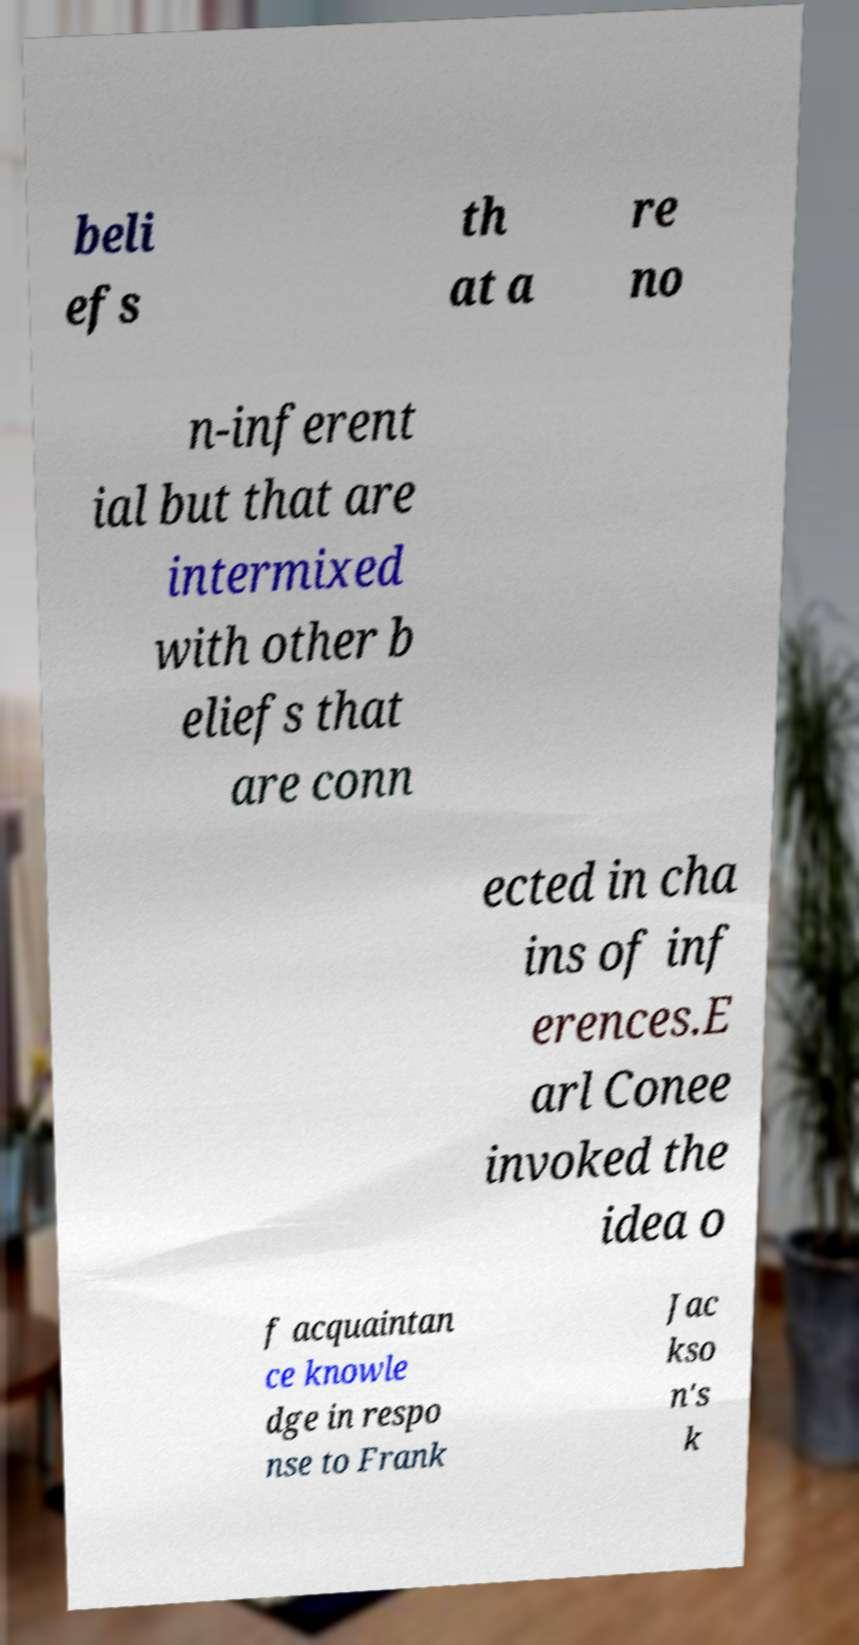Could you assist in decoding the text presented in this image and type it out clearly? beli efs th at a re no n-inferent ial but that are intermixed with other b eliefs that are conn ected in cha ins of inf erences.E arl Conee invoked the idea o f acquaintan ce knowle dge in respo nse to Frank Jac kso n's k 